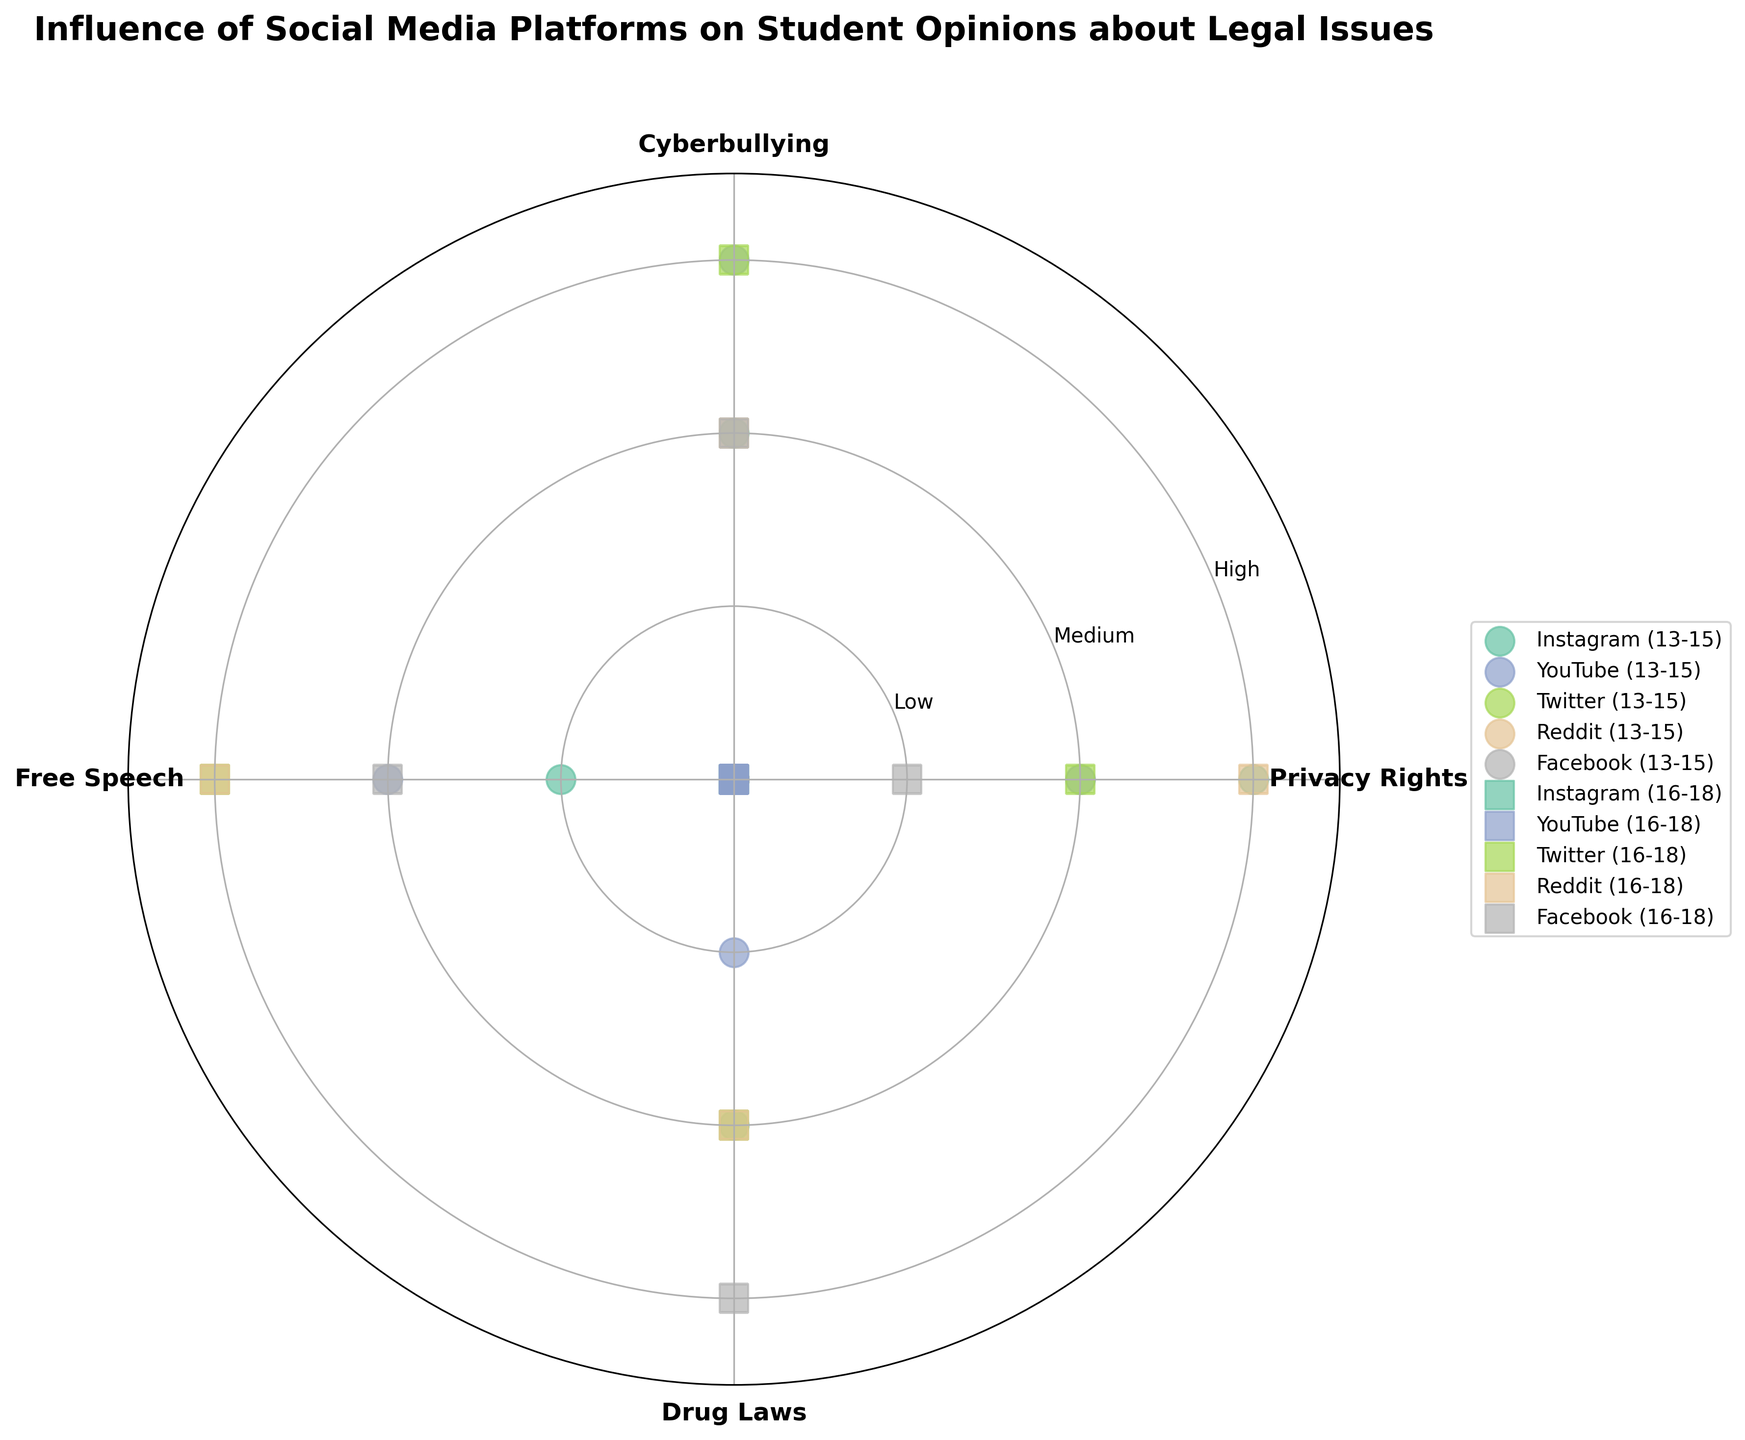What is the main title of the polar scatter chart? The main title is usually located at the top of the chart, providing a summary of what the chart is about. In this case, it's clear from the description of the data that the title is indicative of the chart's purpose: to show the influence of social media platforms on student opinions about legal issues by different age groups.
Answer: Influence of Social Media Platforms on Student Opinions about Legal Issues How many legal issues are being compared in the chart? The legal issues are represented by different angles on the polar scatter chart, each corresponding to a segment along the circumference. By counting these segments or legal issue labels, you can determine the number of different legal issues being compared.
Answer: 4 Which social media platform shows the highest influence level for "Cyberbullying" among the age group 13-15? To find this, look at the data points corresponding to the "Cyberbullying" label and compare the points to gauge their influence levels. Among the platforms Instagram and YouTube for age group 13-15, the highest influence level will be the one represented farthest from the center of the polar chart.
Answer: YouTube Which platform has the most varied influence levels across different legal issues for the age group 16-18? This requires identifying the platform for which the points on the polar scatter chart corresponding to the age group 16-18 are scattered at various distances from the center across the four legal issues. This indicates a variation in influence levels.
Answer: Facebook Of the age groups represented, which one shows more medium-level influences across all legal issues and platforms combined? Medium-level influences are represented by points at a middle distance from the center. Compare the density of medium-level points (those at the second y-tick) for the age groups 13-15 and 16-18 across all platforms and legal issues.
Answer: 16-18 Which social media platform has the least influence over 'Free Speech' in the age group 16-18? Identify the social media platform associated with the point closest to the center (indicating the lowest influence level) for the 'Free Speech' legal issue under the age group 16-18.
Answer: Facebook Which legal issue has the highest average influence level for the age group 16-18? Calculate the average influence level for each legal issue by summing up the influence levels and dividing by the number of social media platforms for the age group 16-18. Compare the averages to determine the highest one.
Answer: Free Speech Do Reddit users show a high influence level for 'Privacy Rights' in the 13-15 age group? Look for a data point labeled 'Privacy Rights' within the 'Reddit' platform circle for the 13-15 age group. Check its position to determine if it is at the high influence level (farthest from the center).
Answer: No Which age group shows more high influence levels for 'Free Speech'? Compare the distances of the 'Free Speech' points from the center for each age group. Higher influence levels should be farthest from the center. Determine which age group has more high influence level points.
Answer: 16-18 